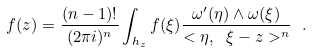<formula> <loc_0><loc_0><loc_500><loc_500>f ( z ) = \frac { ( n - 1 ) ! } { ( 2 \pi i ) ^ { n } } \int _ { h _ { z } } f ( \xi ) \frac { \omega ^ { \prime } ( \eta ) \wedge \omega ( \xi ) } { < \eta , \ \xi - z > ^ { n } } \ .</formula> 